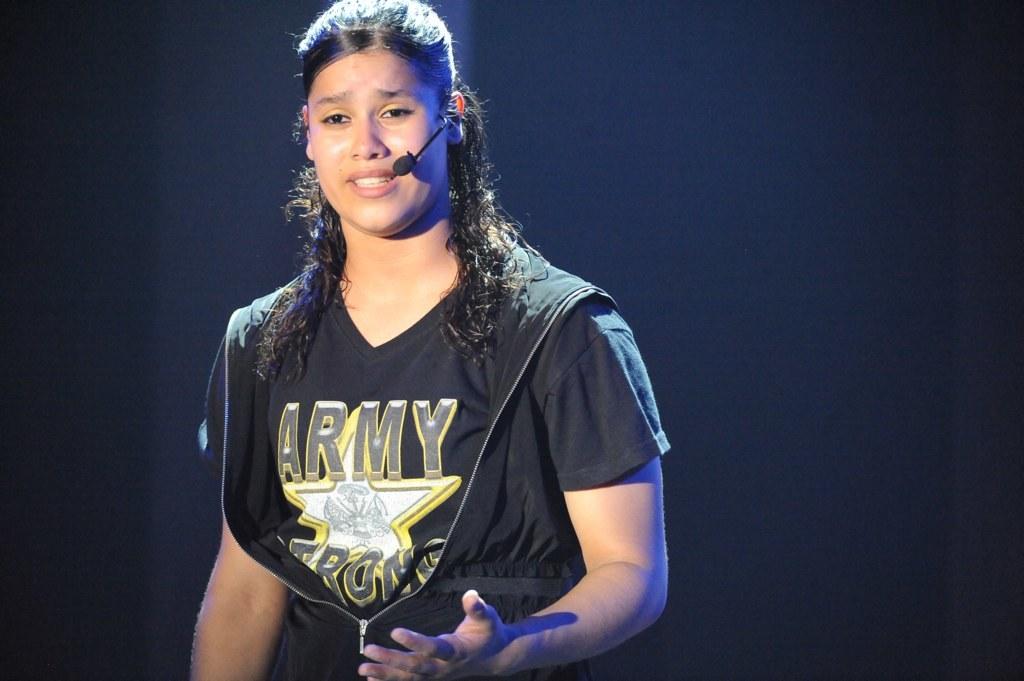What kind of services is featured on her shirt?
Offer a terse response. Army. 